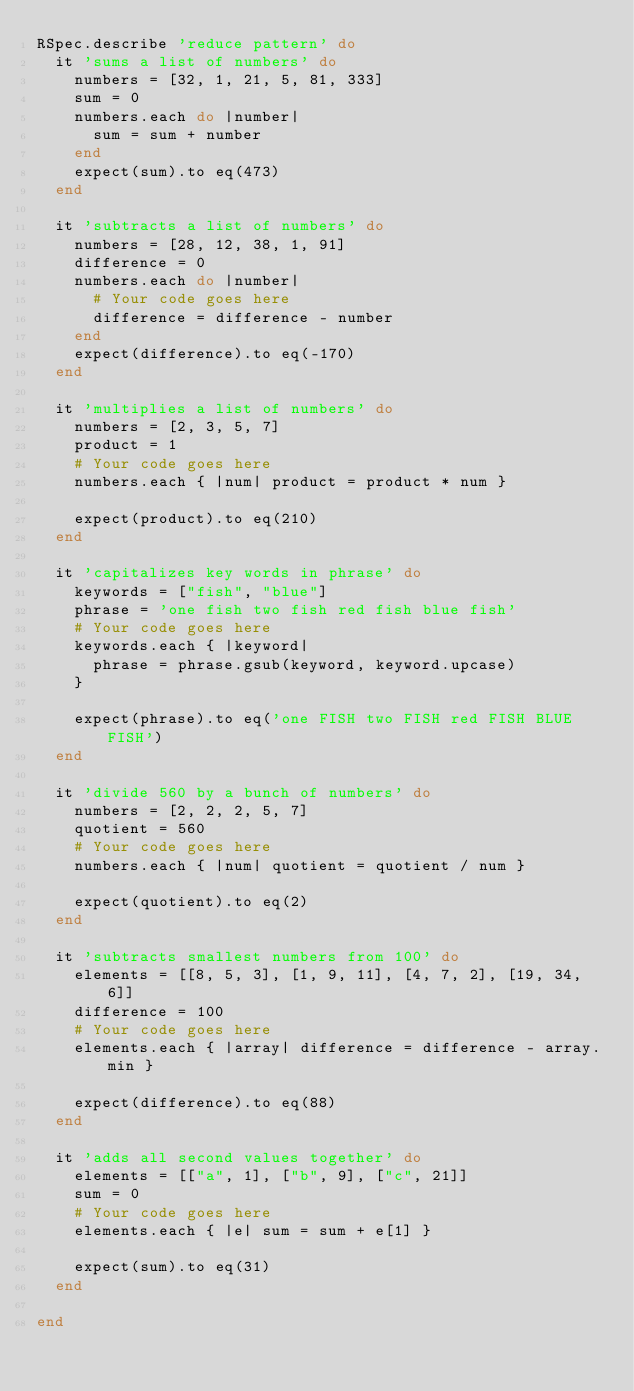Convert code to text. <code><loc_0><loc_0><loc_500><loc_500><_Ruby_>RSpec.describe 'reduce pattern' do
  it 'sums a list of numbers' do
    numbers = [32, 1, 21, 5, 81, 333]
    sum = 0
    numbers.each do |number|
      sum = sum + number
    end
    expect(sum).to eq(473)
  end

  it 'subtracts a list of numbers' do
    numbers = [28, 12, 38, 1, 91]
    difference = 0
    numbers.each do |number|
      # Your code goes here
      difference = difference - number
    end
    expect(difference).to eq(-170)
  end

  it 'multiplies a list of numbers' do
    numbers = [2, 3, 5, 7]
    product = 1
    # Your code goes here
    numbers.each { |num| product = product * num }

    expect(product).to eq(210)
  end

  it 'capitalizes key words in phrase' do
    keywords = ["fish", "blue"]
    phrase = 'one fish two fish red fish blue fish'
    # Your code goes here
    keywords.each { |keyword|
      phrase = phrase.gsub(keyword, keyword.upcase)
    }

    expect(phrase).to eq('one FISH two FISH red FISH BLUE FISH')
  end

  it 'divide 560 by a bunch of numbers' do
    numbers = [2, 2, 2, 5, 7]
    quotient = 560
    # Your code goes here
    numbers.each { |num| quotient = quotient / num }

    expect(quotient).to eq(2)
  end

  it 'subtracts smallest numbers from 100' do
    elements = [[8, 5, 3], [1, 9, 11], [4, 7, 2], [19, 34, 6]]
    difference = 100
    # Your code goes here
    elements.each { |array| difference = difference - array.min }

    expect(difference).to eq(88)
  end

  it 'adds all second values together' do
    elements = [["a", 1], ["b", 9], ["c", 21]]
    sum = 0
    # Your code goes here
    elements.each { |e| sum = sum + e[1] }

    expect(sum).to eq(31)
  end

end
</code> 